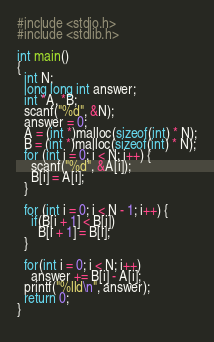<code> <loc_0><loc_0><loc_500><loc_500><_C_>#include <stdio.h>
#include <stdlib.h>

int main()
{
  int N; 
  long long int answer;
  int *A, *B;
  scanf("%d", &N);
  answer = 0;
  A = (int *)malloc(sizeof(int) * N);
  B = (int *)malloc(sizeof(int) * N);
  for (int i = 0; i < N; i++) {
    scanf("%d", &A[i]);
    B[i] = A[i];
  }
  
  for (int i = 0; i < N - 1; i++) {
    if(B[i + 1] < B[i])
      B[i + 1] = B[i];
  }
  
  for(int i = 0; i < N; i++)
    answer += B[i] - A[i];
  printf("%lld\n", answer);
  return 0;
}
  </code> 